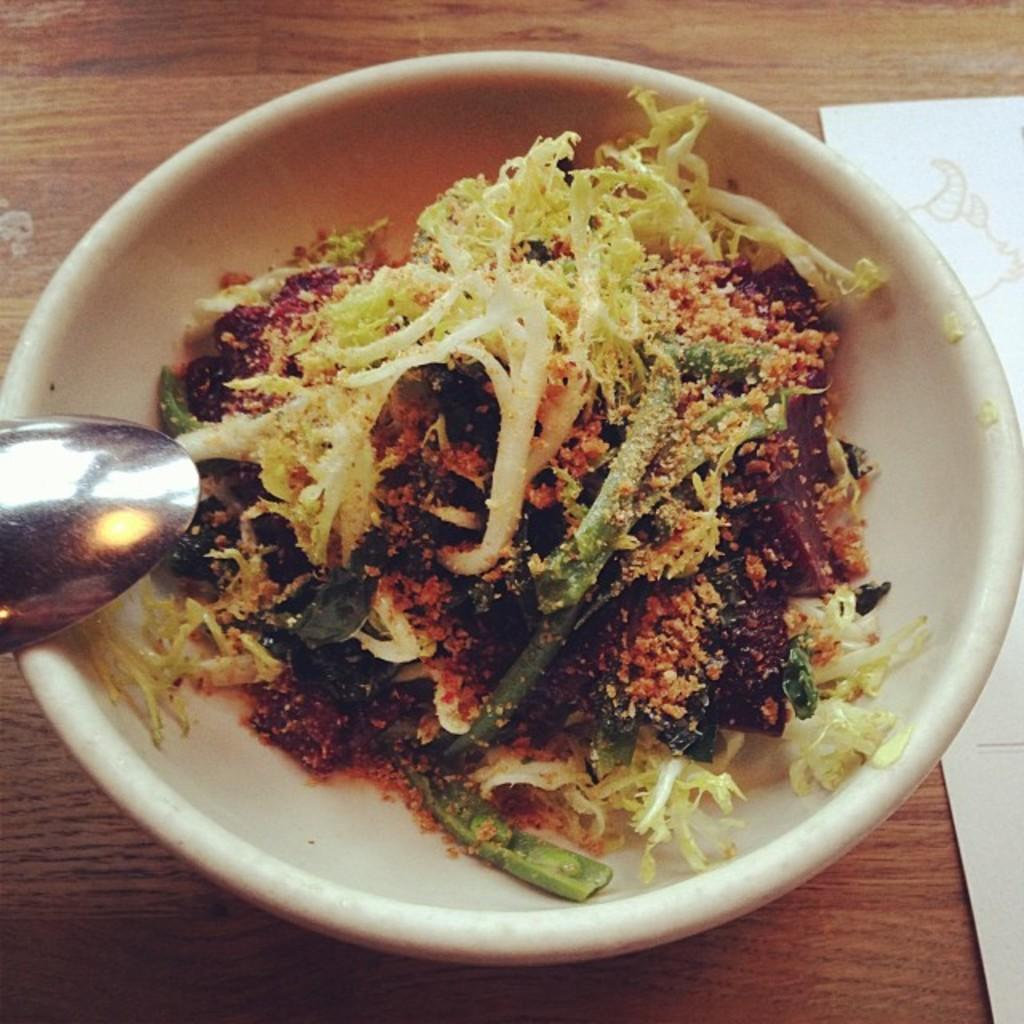What is in the bowl that is visible in the image? There is a bowl of food in the image. What utensil is present in the image? There is a spoon in the image. What can be seen on the wooden surface in the image? There is a paper on a wooden surface in the image. What type of flowers are growing in the tin can in the image? There is no tin can or flowers present in the image. 